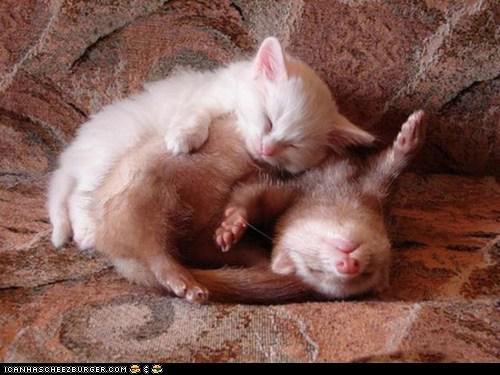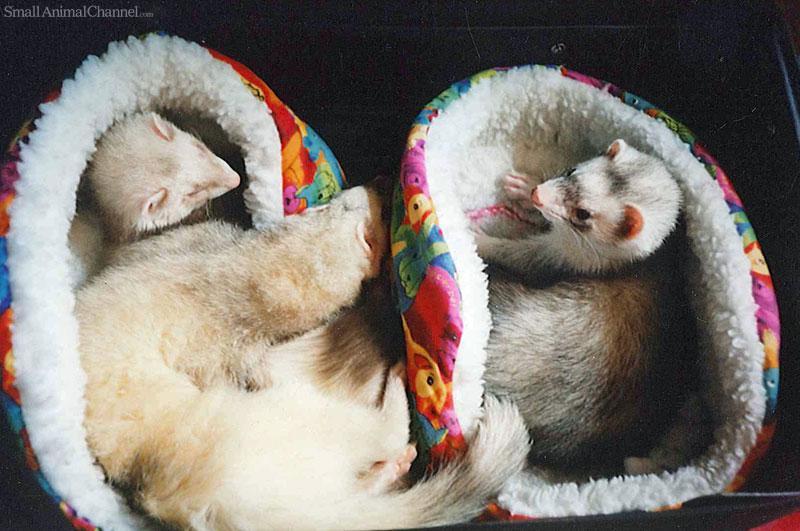The first image is the image on the left, the second image is the image on the right. Given the left and right images, does the statement "One image shows two ferrets sleeping with a cat in between them, and the other shows exactly two animal faces side-by-side." hold true? Answer yes or no. No. 